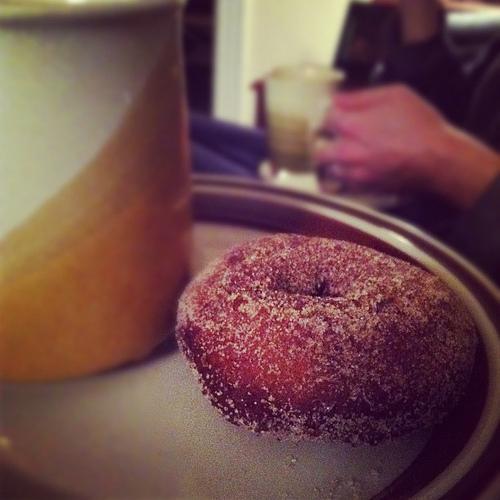How many donuts are there?
Give a very brief answer. 1. How many objects are holding by a person?
Give a very brief answer. 1. 